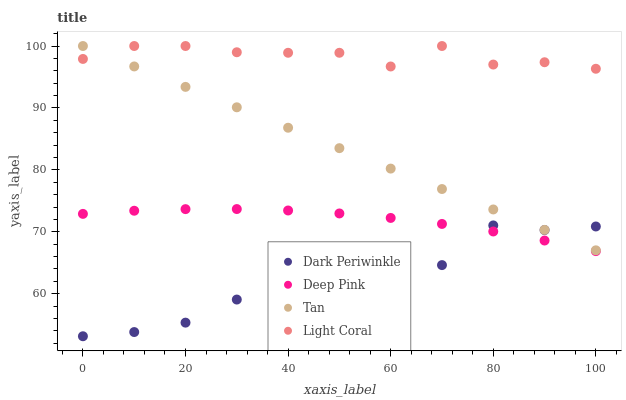Does Dark Periwinkle have the minimum area under the curve?
Answer yes or no. Yes. Does Light Coral have the maximum area under the curve?
Answer yes or no. Yes. Does Tan have the minimum area under the curve?
Answer yes or no. No. Does Tan have the maximum area under the curve?
Answer yes or no. No. Is Tan the smoothest?
Answer yes or no. Yes. Is Dark Periwinkle the roughest?
Answer yes or no. Yes. Is Deep Pink the smoothest?
Answer yes or no. No. Is Deep Pink the roughest?
Answer yes or no. No. Does Dark Periwinkle have the lowest value?
Answer yes or no. Yes. Does Tan have the lowest value?
Answer yes or no. No. Does Tan have the highest value?
Answer yes or no. Yes. Does Deep Pink have the highest value?
Answer yes or no. No. Is Deep Pink less than Light Coral?
Answer yes or no. Yes. Is Light Coral greater than Dark Periwinkle?
Answer yes or no. Yes. Does Light Coral intersect Tan?
Answer yes or no. Yes. Is Light Coral less than Tan?
Answer yes or no. No. Is Light Coral greater than Tan?
Answer yes or no. No. Does Deep Pink intersect Light Coral?
Answer yes or no. No. 